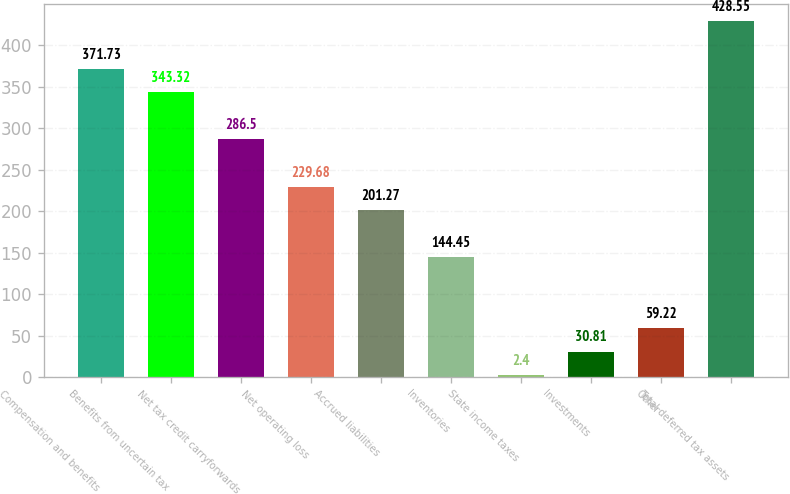Convert chart. <chart><loc_0><loc_0><loc_500><loc_500><bar_chart><fcel>Compensation and benefits<fcel>Benefits from uncertain tax<fcel>Net tax credit carryforwards<fcel>Net operating loss<fcel>Accrued liabilities<fcel>Inventories<fcel>State income taxes<fcel>Investments<fcel>Other<fcel>Total deferred tax assets<nl><fcel>371.73<fcel>343.32<fcel>286.5<fcel>229.68<fcel>201.27<fcel>144.45<fcel>2.4<fcel>30.81<fcel>59.22<fcel>428.55<nl></chart> 